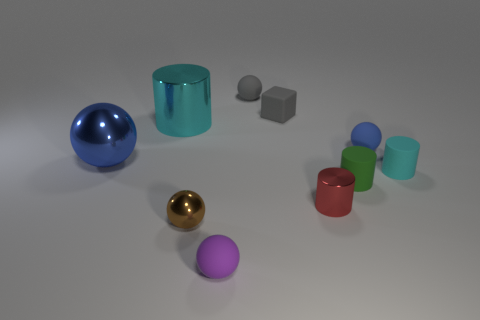There is a blue ball right of the small rubber sphere in front of the small cylinder that is in front of the small green matte cylinder; what is its material?
Ensure brevity in your answer.  Rubber. Is the size of the blue sphere that is on the left side of the purple matte sphere the same as the big cyan shiny cylinder?
Offer a very short reply. Yes. What is the blue sphere that is left of the gray matte sphere made of?
Offer a very short reply. Metal. Are there more small gray objects than tiny matte things?
Your response must be concise. No. How many objects are spheres in front of the green cylinder or tiny red metal cylinders?
Keep it short and to the point. 3. There is a shiny cylinder to the left of the small red shiny cylinder; how many blue things are to the left of it?
Offer a very short reply. 1. What size is the shiny cylinder that is in front of the cylinder behind the large blue thing left of the small shiny ball?
Make the answer very short. Small. There is a sphere on the right side of the gray matte sphere; does it have the same color as the large metallic ball?
Ensure brevity in your answer.  Yes. What size is the other blue thing that is the same shape as the tiny blue matte thing?
Offer a terse response. Large. How many things are either shiny objects that are on the right side of the purple sphere or objects on the left side of the tiny cyan object?
Keep it short and to the point. 9. 